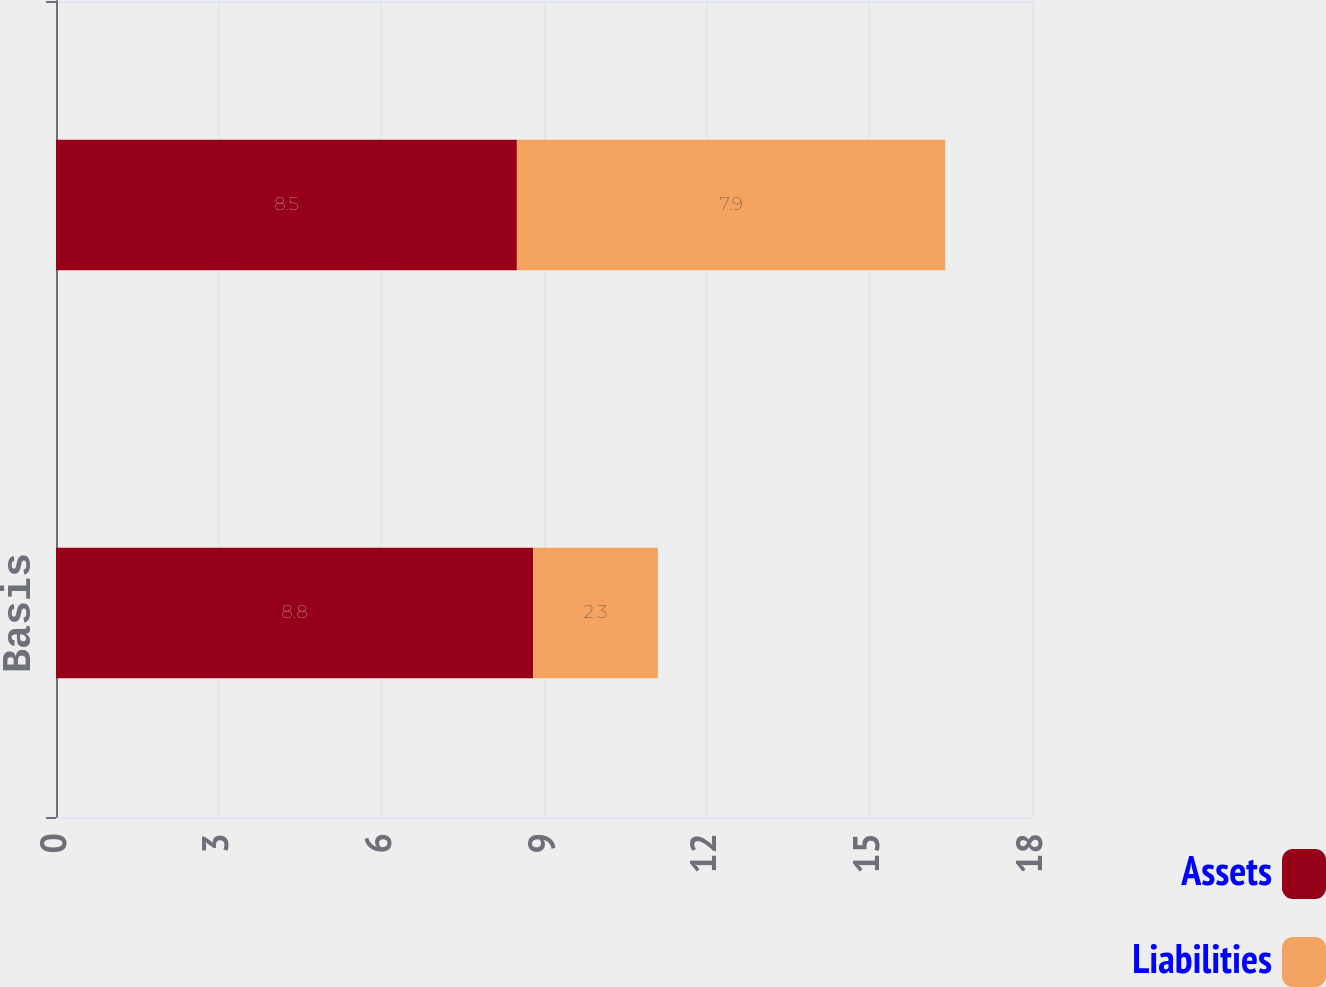Convert chart to OTSL. <chart><loc_0><loc_0><loc_500><loc_500><stacked_bar_chart><ecel><fcel>Basis<fcel>Transportation cost<nl><fcel>Assets<fcel>8.8<fcel>8.5<nl><fcel>Liabilities<fcel>2.3<fcel>7.9<nl></chart> 